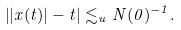<formula> <loc_0><loc_0><loc_500><loc_500>\left | | x ( t ) | - t \right | \lesssim _ { u } N ( 0 ) ^ { - 1 } .</formula> 